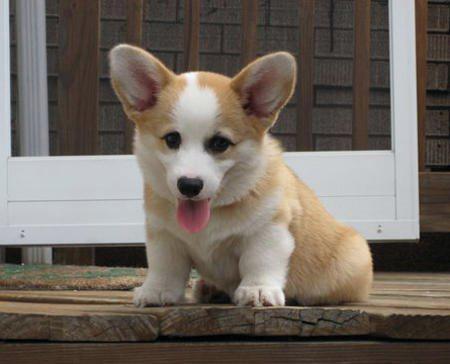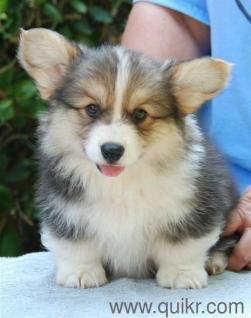The first image is the image on the left, the second image is the image on the right. Analyze the images presented: Is the assertion "There are three dogs in the right image." valid? Answer yes or no. No. The first image is the image on the left, the second image is the image on the right. Given the left and right images, does the statement "There are four dogs." hold true? Answer yes or no. No. 